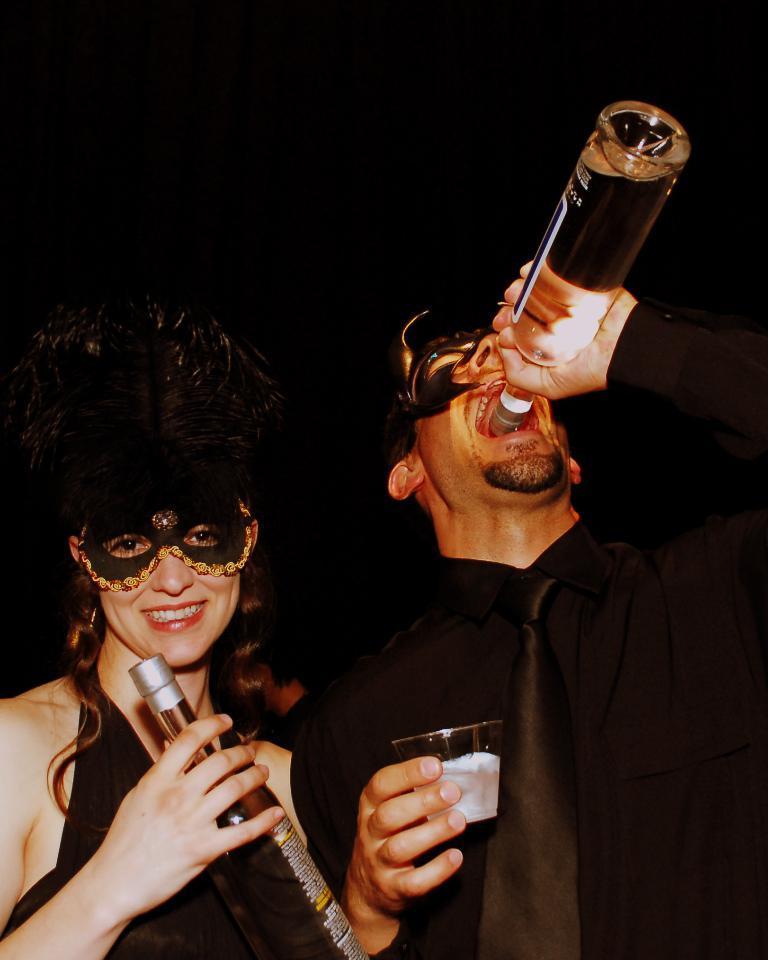How would you summarize this image in a sentence or two? This picture shows man drinking some drink in the bottle, holding a glass in his hand and a woman also holding a bottle in her hands. She is smiling, wearing a head mask. 